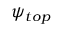Convert formula to latex. <formula><loc_0><loc_0><loc_500><loc_500>\psi _ { t o p }</formula> 